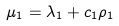Convert formula to latex. <formula><loc_0><loc_0><loc_500><loc_500>\mu _ { 1 } = \lambda _ { 1 } + c _ { 1 } \rho _ { 1 }</formula> 